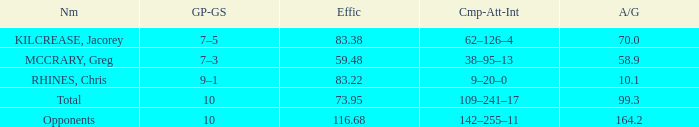What is the avg/g of Rhines, Chris, who has an effic greater than 73.95? 10.1. 